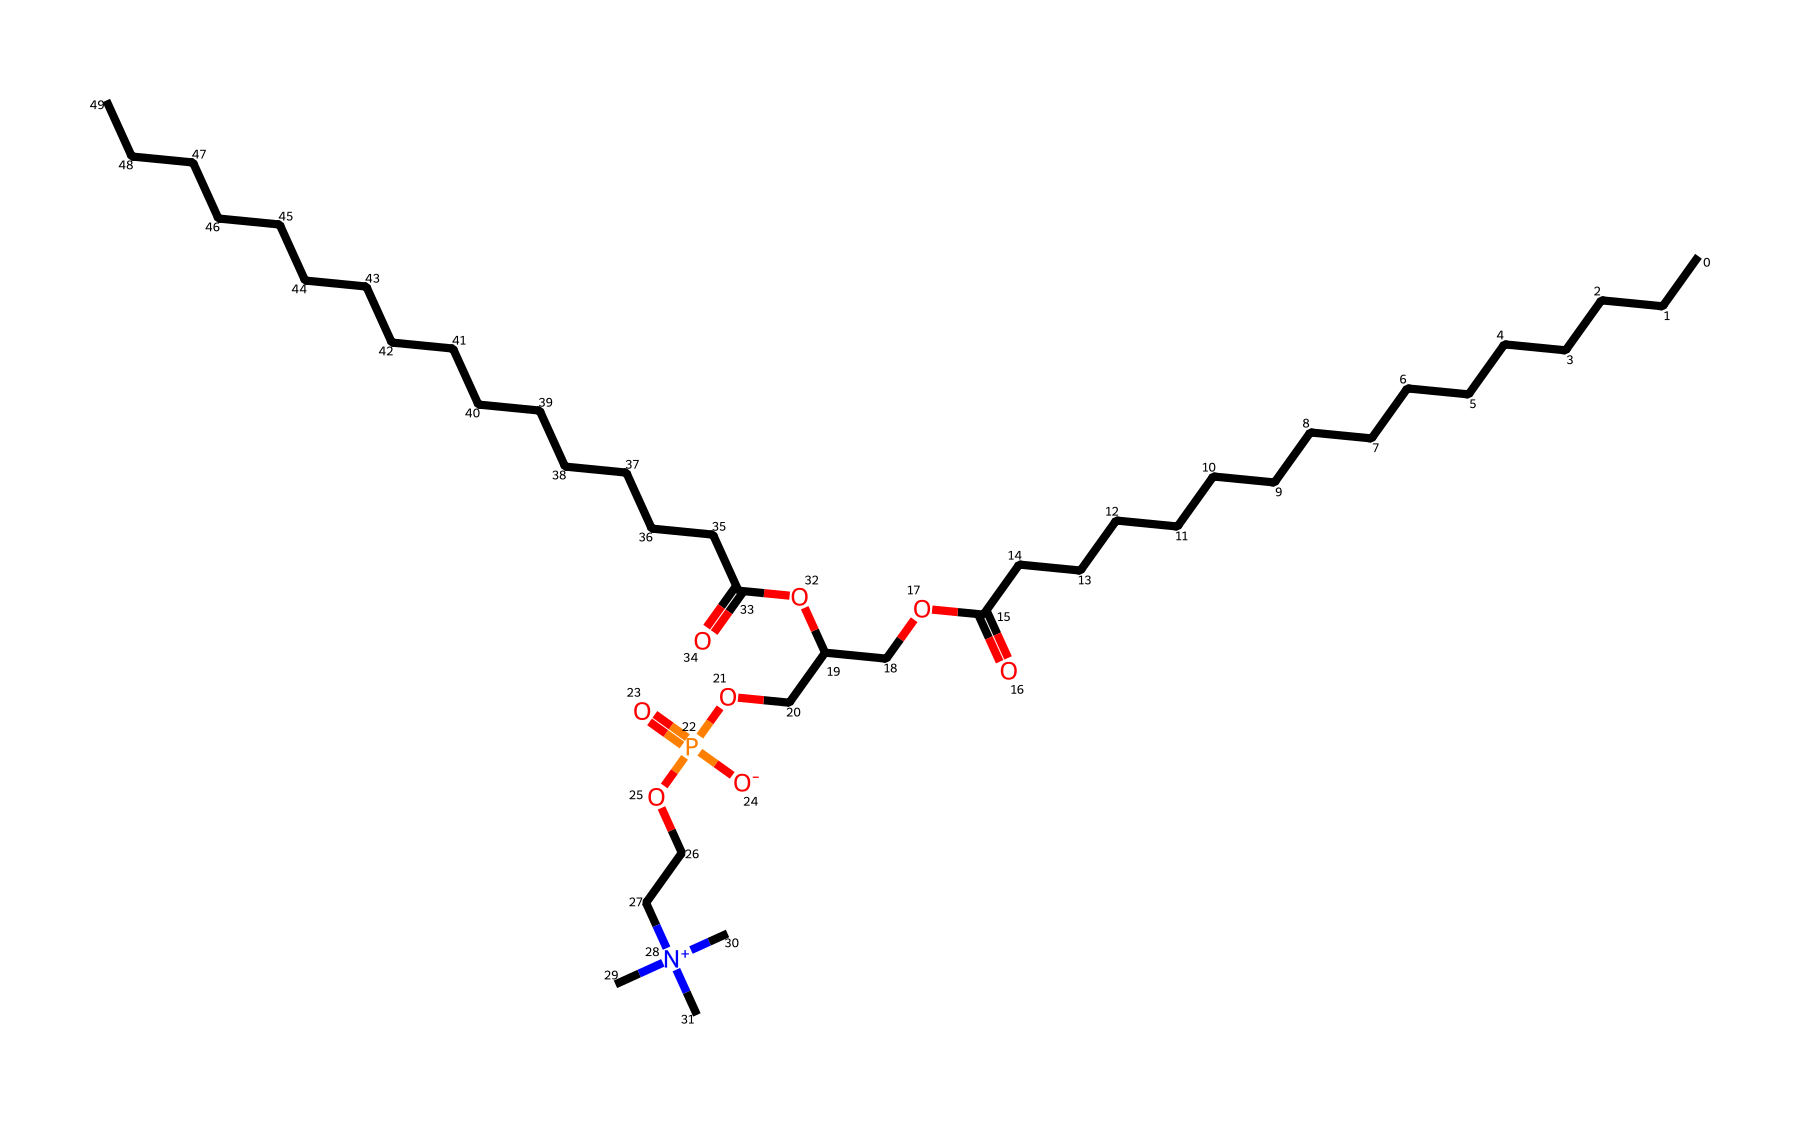What type of lipid is represented by this structure? The presence of both hydrophobic carbon chains and a phosphate group indicates that it is a phospholipid, which is a type of lipid.
Answer: phospholipid How many carbon atoms are in this molecule? By analyzing the structure and counting the carbon (C) symbols, there are 30 carbon atoms present in the molecule.
Answer: 30 What functional groups are present in this chemical? The chemical contains a carboxylic acid (-COOH), an ester (-O-), and a phosphate group (-PO4) indicating functional diversity.
Answer: carboxylic acid, ester, phosphate What is the charge of the phosphate moiety in this structure? The phosphate group is indicated by the presence of the ionized oxygen (-O-) associated with it, suggesting that it has a negative charge.
Answer: negative How does this lipid contribute to membrane formation? The hydrophilic (water-attracting) phosphate head and hydrophobic (water-repelling) fatty acid tails allow for the formation of bilayers, essential for cell membranes.
Answer: bilayer formation What role does this molecule play in cell signaling? The presence of the phosphoryl group allows it to act as a signaling molecule, influencing various cellular processes such as signaling pathways.
Answer: signaling molecule 